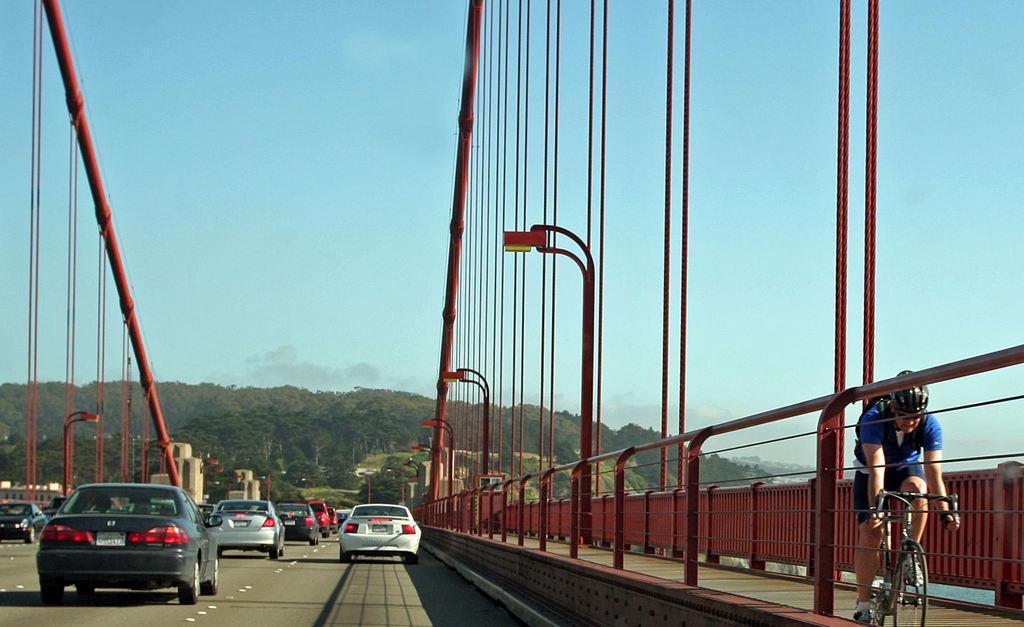Describe this image in one or two sentences. In this image we can see many cars passing on the bridge. On the right there is a person riding the bicycle. In the background there is a mountain with full of trees. Sky is also visible in this image. 